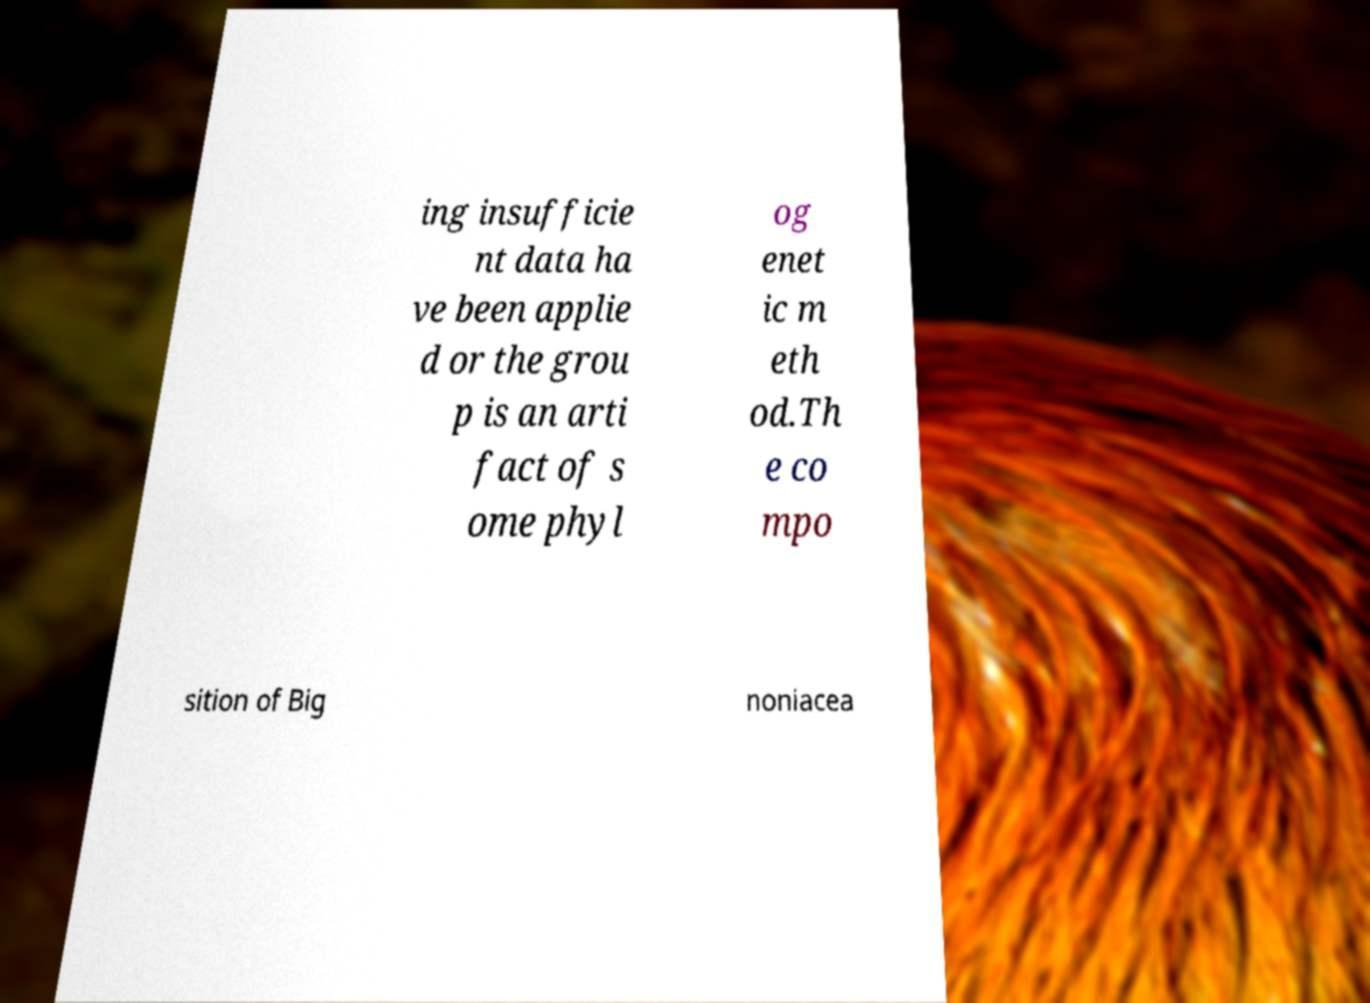Please read and relay the text visible in this image. What does it say? ing insufficie nt data ha ve been applie d or the grou p is an arti fact of s ome phyl og enet ic m eth od.Th e co mpo sition of Big noniacea 